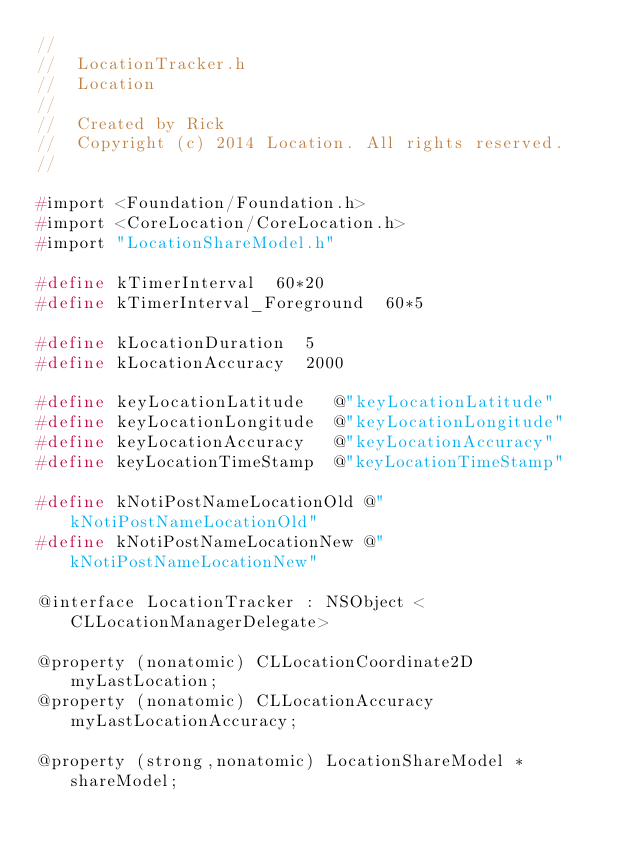<code> <loc_0><loc_0><loc_500><loc_500><_C_>//
//  LocationTracker.h
//  Location
//
//  Created by Rick
//  Copyright (c) 2014 Location. All rights reserved.
//

#import <Foundation/Foundation.h>
#import <CoreLocation/CoreLocation.h>
#import "LocationShareModel.h"

#define kTimerInterval  60*20
#define kTimerInterval_Foreground  60*5

#define kLocationDuration  5
#define kLocationAccuracy  2000

#define keyLocationLatitude   @"keyLocationLatitude"
#define keyLocationLongitude  @"keyLocationLongitude"
#define keyLocationAccuracy   @"keyLocationAccuracy"
#define keyLocationTimeStamp  @"keyLocationTimeStamp"

#define kNotiPostNameLocationOld @"kNotiPostNameLocationOld"
#define kNotiPostNameLocationNew @"kNotiPostNameLocationNew"

@interface LocationTracker : NSObject <CLLocationManagerDelegate>

@property (nonatomic) CLLocationCoordinate2D myLastLocation;
@property (nonatomic) CLLocationAccuracy myLastLocationAccuracy;

@property (strong,nonatomic) LocationShareModel * shareModel;
</code> 